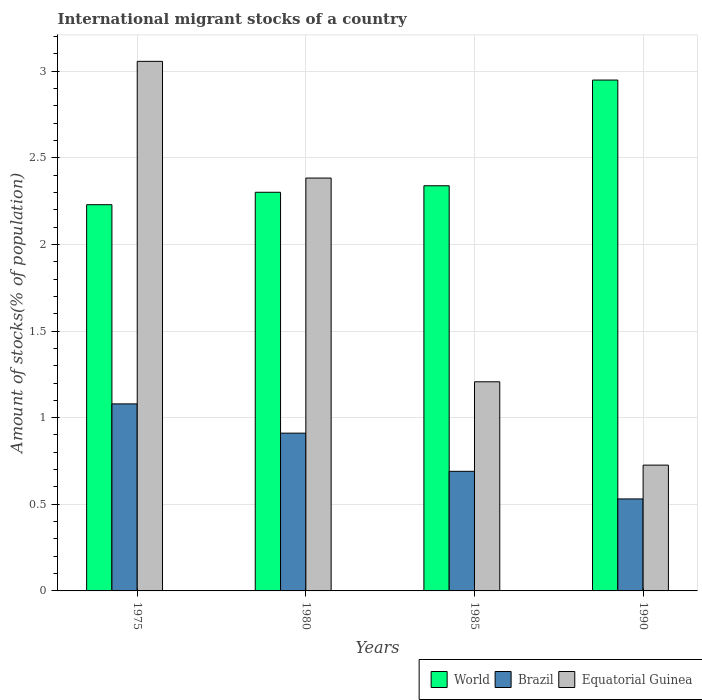Are the number of bars on each tick of the X-axis equal?
Give a very brief answer. Yes. How many bars are there on the 1st tick from the right?
Keep it short and to the point. 3. What is the label of the 1st group of bars from the left?
Provide a succinct answer. 1975. What is the amount of stocks in in Brazil in 1975?
Your response must be concise. 1.08. Across all years, what is the maximum amount of stocks in in Brazil?
Ensure brevity in your answer.  1.08. Across all years, what is the minimum amount of stocks in in Equatorial Guinea?
Provide a short and direct response. 0.73. In which year was the amount of stocks in in Brazil maximum?
Provide a succinct answer. 1975. In which year was the amount of stocks in in World minimum?
Provide a succinct answer. 1975. What is the total amount of stocks in in World in the graph?
Make the answer very short. 9.82. What is the difference between the amount of stocks in in Equatorial Guinea in 1975 and that in 1990?
Provide a short and direct response. 2.33. What is the difference between the amount of stocks in in World in 1975 and the amount of stocks in in Brazil in 1990?
Make the answer very short. 1.7. What is the average amount of stocks in in Brazil per year?
Provide a succinct answer. 0.8. In the year 1985, what is the difference between the amount of stocks in in Equatorial Guinea and amount of stocks in in World?
Offer a very short reply. -1.13. In how many years, is the amount of stocks in in Brazil greater than 2.1 %?
Provide a succinct answer. 0. What is the ratio of the amount of stocks in in Equatorial Guinea in 1980 to that in 1985?
Your answer should be compact. 1.97. Is the amount of stocks in in Equatorial Guinea in 1975 less than that in 1980?
Provide a short and direct response. No. Is the difference between the amount of stocks in in Equatorial Guinea in 1985 and 1990 greater than the difference between the amount of stocks in in World in 1985 and 1990?
Make the answer very short. Yes. What is the difference between the highest and the second highest amount of stocks in in World?
Offer a very short reply. 0.61. What is the difference between the highest and the lowest amount of stocks in in World?
Provide a short and direct response. 0.72. What does the 3rd bar from the left in 1990 represents?
Your response must be concise. Equatorial Guinea. What is the difference between two consecutive major ticks on the Y-axis?
Offer a terse response. 0.5. Are the values on the major ticks of Y-axis written in scientific E-notation?
Your answer should be compact. No. Does the graph contain any zero values?
Your answer should be compact. No. How many legend labels are there?
Make the answer very short. 3. What is the title of the graph?
Provide a succinct answer. International migrant stocks of a country. Does "East Asia (developing only)" appear as one of the legend labels in the graph?
Make the answer very short. No. What is the label or title of the Y-axis?
Provide a short and direct response. Amount of stocks(% of population). What is the Amount of stocks(% of population) of World in 1975?
Offer a terse response. 2.23. What is the Amount of stocks(% of population) of Brazil in 1975?
Provide a succinct answer. 1.08. What is the Amount of stocks(% of population) in Equatorial Guinea in 1975?
Your answer should be very brief. 3.06. What is the Amount of stocks(% of population) of World in 1980?
Your answer should be compact. 2.3. What is the Amount of stocks(% of population) in Brazil in 1980?
Provide a short and direct response. 0.91. What is the Amount of stocks(% of population) of Equatorial Guinea in 1980?
Keep it short and to the point. 2.38. What is the Amount of stocks(% of population) in World in 1985?
Give a very brief answer. 2.34. What is the Amount of stocks(% of population) in Brazil in 1985?
Your response must be concise. 0.69. What is the Amount of stocks(% of population) of Equatorial Guinea in 1985?
Your response must be concise. 1.21. What is the Amount of stocks(% of population) of World in 1990?
Ensure brevity in your answer.  2.95. What is the Amount of stocks(% of population) of Brazil in 1990?
Provide a succinct answer. 0.53. What is the Amount of stocks(% of population) of Equatorial Guinea in 1990?
Offer a terse response. 0.73. Across all years, what is the maximum Amount of stocks(% of population) in World?
Offer a very short reply. 2.95. Across all years, what is the maximum Amount of stocks(% of population) of Brazil?
Keep it short and to the point. 1.08. Across all years, what is the maximum Amount of stocks(% of population) in Equatorial Guinea?
Give a very brief answer. 3.06. Across all years, what is the minimum Amount of stocks(% of population) in World?
Your answer should be very brief. 2.23. Across all years, what is the minimum Amount of stocks(% of population) of Brazil?
Make the answer very short. 0.53. Across all years, what is the minimum Amount of stocks(% of population) in Equatorial Guinea?
Offer a very short reply. 0.73. What is the total Amount of stocks(% of population) in World in the graph?
Offer a very short reply. 9.82. What is the total Amount of stocks(% of population) of Brazil in the graph?
Provide a succinct answer. 3.21. What is the total Amount of stocks(% of population) in Equatorial Guinea in the graph?
Provide a succinct answer. 7.37. What is the difference between the Amount of stocks(% of population) of World in 1975 and that in 1980?
Keep it short and to the point. -0.07. What is the difference between the Amount of stocks(% of population) in Brazil in 1975 and that in 1980?
Offer a very short reply. 0.17. What is the difference between the Amount of stocks(% of population) in Equatorial Guinea in 1975 and that in 1980?
Your response must be concise. 0.67. What is the difference between the Amount of stocks(% of population) in World in 1975 and that in 1985?
Your response must be concise. -0.11. What is the difference between the Amount of stocks(% of population) of Brazil in 1975 and that in 1985?
Offer a very short reply. 0.39. What is the difference between the Amount of stocks(% of population) of Equatorial Guinea in 1975 and that in 1985?
Your response must be concise. 1.85. What is the difference between the Amount of stocks(% of population) of World in 1975 and that in 1990?
Offer a terse response. -0.72. What is the difference between the Amount of stocks(% of population) of Brazil in 1975 and that in 1990?
Make the answer very short. 0.55. What is the difference between the Amount of stocks(% of population) of Equatorial Guinea in 1975 and that in 1990?
Offer a very short reply. 2.33. What is the difference between the Amount of stocks(% of population) in World in 1980 and that in 1985?
Offer a very short reply. -0.04. What is the difference between the Amount of stocks(% of population) in Brazil in 1980 and that in 1985?
Your answer should be very brief. 0.22. What is the difference between the Amount of stocks(% of population) of Equatorial Guinea in 1980 and that in 1985?
Provide a short and direct response. 1.18. What is the difference between the Amount of stocks(% of population) in World in 1980 and that in 1990?
Give a very brief answer. -0.65. What is the difference between the Amount of stocks(% of population) of Brazil in 1980 and that in 1990?
Provide a short and direct response. 0.38. What is the difference between the Amount of stocks(% of population) in Equatorial Guinea in 1980 and that in 1990?
Your answer should be compact. 1.66. What is the difference between the Amount of stocks(% of population) in World in 1985 and that in 1990?
Your answer should be very brief. -0.61. What is the difference between the Amount of stocks(% of population) in Brazil in 1985 and that in 1990?
Your answer should be very brief. 0.16. What is the difference between the Amount of stocks(% of population) in Equatorial Guinea in 1985 and that in 1990?
Make the answer very short. 0.48. What is the difference between the Amount of stocks(% of population) in World in 1975 and the Amount of stocks(% of population) in Brazil in 1980?
Your answer should be very brief. 1.32. What is the difference between the Amount of stocks(% of population) in World in 1975 and the Amount of stocks(% of population) in Equatorial Guinea in 1980?
Offer a terse response. -0.15. What is the difference between the Amount of stocks(% of population) of Brazil in 1975 and the Amount of stocks(% of population) of Equatorial Guinea in 1980?
Your response must be concise. -1.3. What is the difference between the Amount of stocks(% of population) of World in 1975 and the Amount of stocks(% of population) of Brazil in 1985?
Your answer should be compact. 1.54. What is the difference between the Amount of stocks(% of population) of World in 1975 and the Amount of stocks(% of population) of Equatorial Guinea in 1985?
Give a very brief answer. 1.02. What is the difference between the Amount of stocks(% of population) in Brazil in 1975 and the Amount of stocks(% of population) in Equatorial Guinea in 1985?
Offer a terse response. -0.13. What is the difference between the Amount of stocks(% of population) in World in 1975 and the Amount of stocks(% of population) in Brazil in 1990?
Your answer should be compact. 1.7. What is the difference between the Amount of stocks(% of population) in World in 1975 and the Amount of stocks(% of population) in Equatorial Guinea in 1990?
Your answer should be very brief. 1.5. What is the difference between the Amount of stocks(% of population) of Brazil in 1975 and the Amount of stocks(% of population) of Equatorial Guinea in 1990?
Give a very brief answer. 0.35. What is the difference between the Amount of stocks(% of population) in World in 1980 and the Amount of stocks(% of population) in Brazil in 1985?
Your response must be concise. 1.61. What is the difference between the Amount of stocks(% of population) of World in 1980 and the Amount of stocks(% of population) of Equatorial Guinea in 1985?
Your answer should be very brief. 1.09. What is the difference between the Amount of stocks(% of population) in Brazil in 1980 and the Amount of stocks(% of population) in Equatorial Guinea in 1985?
Offer a very short reply. -0.3. What is the difference between the Amount of stocks(% of population) of World in 1980 and the Amount of stocks(% of population) of Brazil in 1990?
Provide a succinct answer. 1.77. What is the difference between the Amount of stocks(% of population) of World in 1980 and the Amount of stocks(% of population) of Equatorial Guinea in 1990?
Give a very brief answer. 1.57. What is the difference between the Amount of stocks(% of population) of Brazil in 1980 and the Amount of stocks(% of population) of Equatorial Guinea in 1990?
Your answer should be compact. 0.18. What is the difference between the Amount of stocks(% of population) of World in 1985 and the Amount of stocks(% of population) of Brazil in 1990?
Give a very brief answer. 1.81. What is the difference between the Amount of stocks(% of population) in World in 1985 and the Amount of stocks(% of population) in Equatorial Guinea in 1990?
Your answer should be very brief. 1.61. What is the difference between the Amount of stocks(% of population) of Brazil in 1985 and the Amount of stocks(% of population) of Equatorial Guinea in 1990?
Provide a short and direct response. -0.04. What is the average Amount of stocks(% of population) of World per year?
Your answer should be very brief. 2.45. What is the average Amount of stocks(% of population) in Brazil per year?
Keep it short and to the point. 0.8. What is the average Amount of stocks(% of population) in Equatorial Guinea per year?
Keep it short and to the point. 1.84. In the year 1975, what is the difference between the Amount of stocks(% of population) in World and Amount of stocks(% of population) in Brazil?
Ensure brevity in your answer.  1.15. In the year 1975, what is the difference between the Amount of stocks(% of population) of World and Amount of stocks(% of population) of Equatorial Guinea?
Ensure brevity in your answer.  -0.83. In the year 1975, what is the difference between the Amount of stocks(% of population) of Brazil and Amount of stocks(% of population) of Equatorial Guinea?
Your answer should be very brief. -1.98. In the year 1980, what is the difference between the Amount of stocks(% of population) in World and Amount of stocks(% of population) in Brazil?
Keep it short and to the point. 1.39. In the year 1980, what is the difference between the Amount of stocks(% of population) of World and Amount of stocks(% of population) of Equatorial Guinea?
Ensure brevity in your answer.  -0.08. In the year 1980, what is the difference between the Amount of stocks(% of population) of Brazil and Amount of stocks(% of population) of Equatorial Guinea?
Offer a very short reply. -1.47. In the year 1985, what is the difference between the Amount of stocks(% of population) of World and Amount of stocks(% of population) of Brazil?
Make the answer very short. 1.65. In the year 1985, what is the difference between the Amount of stocks(% of population) in World and Amount of stocks(% of population) in Equatorial Guinea?
Provide a short and direct response. 1.13. In the year 1985, what is the difference between the Amount of stocks(% of population) of Brazil and Amount of stocks(% of population) of Equatorial Guinea?
Your answer should be compact. -0.52. In the year 1990, what is the difference between the Amount of stocks(% of population) of World and Amount of stocks(% of population) of Brazil?
Keep it short and to the point. 2.42. In the year 1990, what is the difference between the Amount of stocks(% of population) in World and Amount of stocks(% of population) in Equatorial Guinea?
Provide a succinct answer. 2.22. In the year 1990, what is the difference between the Amount of stocks(% of population) in Brazil and Amount of stocks(% of population) in Equatorial Guinea?
Offer a very short reply. -0.2. What is the ratio of the Amount of stocks(% of population) in World in 1975 to that in 1980?
Give a very brief answer. 0.97. What is the ratio of the Amount of stocks(% of population) of Brazil in 1975 to that in 1980?
Provide a succinct answer. 1.19. What is the ratio of the Amount of stocks(% of population) in Equatorial Guinea in 1975 to that in 1980?
Your answer should be compact. 1.28. What is the ratio of the Amount of stocks(% of population) of World in 1975 to that in 1985?
Provide a short and direct response. 0.95. What is the ratio of the Amount of stocks(% of population) in Brazil in 1975 to that in 1985?
Your response must be concise. 1.56. What is the ratio of the Amount of stocks(% of population) of Equatorial Guinea in 1975 to that in 1985?
Give a very brief answer. 2.53. What is the ratio of the Amount of stocks(% of population) of World in 1975 to that in 1990?
Provide a short and direct response. 0.76. What is the ratio of the Amount of stocks(% of population) in Brazil in 1975 to that in 1990?
Your answer should be very brief. 2.03. What is the ratio of the Amount of stocks(% of population) in Equatorial Guinea in 1975 to that in 1990?
Your answer should be very brief. 4.21. What is the ratio of the Amount of stocks(% of population) in World in 1980 to that in 1985?
Give a very brief answer. 0.98. What is the ratio of the Amount of stocks(% of population) of Brazil in 1980 to that in 1985?
Make the answer very short. 1.32. What is the ratio of the Amount of stocks(% of population) in Equatorial Guinea in 1980 to that in 1985?
Offer a very short reply. 1.97. What is the ratio of the Amount of stocks(% of population) of World in 1980 to that in 1990?
Your response must be concise. 0.78. What is the ratio of the Amount of stocks(% of population) of Brazil in 1980 to that in 1990?
Make the answer very short. 1.72. What is the ratio of the Amount of stocks(% of population) of Equatorial Guinea in 1980 to that in 1990?
Make the answer very short. 3.28. What is the ratio of the Amount of stocks(% of population) in World in 1985 to that in 1990?
Your response must be concise. 0.79. What is the ratio of the Amount of stocks(% of population) in Brazil in 1985 to that in 1990?
Make the answer very short. 1.3. What is the ratio of the Amount of stocks(% of population) of Equatorial Guinea in 1985 to that in 1990?
Keep it short and to the point. 1.66. What is the difference between the highest and the second highest Amount of stocks(% of population) in World?
Make the answer very short. 0.61. What is the difference between the highest and the second highest Amount of stocks(% of population) in Brazil?
Provide a short and direct response. 0.17. What is the difference between the highest and the second highest Amount of stocks(% of population) in Equatorial Guinea?
Offer a terse response. 0.67. What is the difference between the highest and the lowest Amount of stocks(% of population) in World?
Offer a very short reply. 0.72. What is the difference between the highest and the lowest Amount of stocks(% of population) in Brazil?
Offer a very short reply. 0.55. What is the difference between the highest and the lowest Amount of stocks(% of population) of Equatorial Guinea?
Provide a short and direct response. 2.33. 